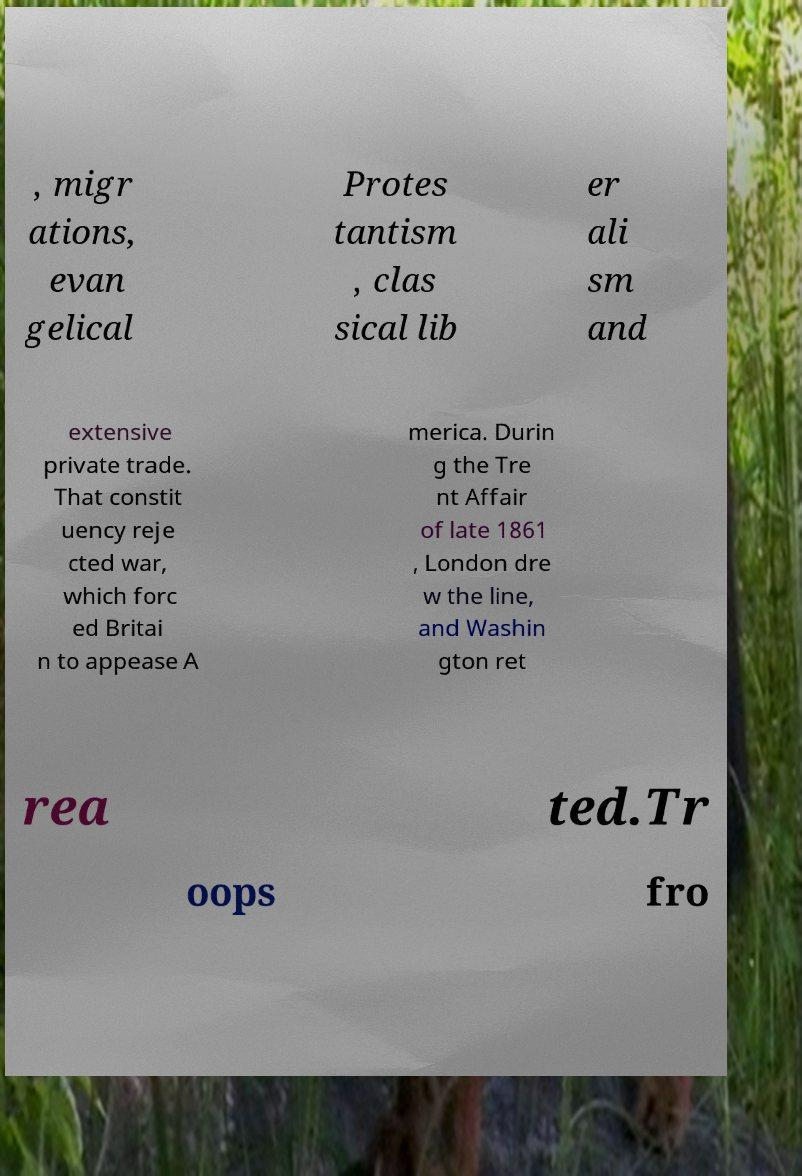I need the written content from this picture converted into text. Can you do that? , migr ations, evan gelical Protes tantism , clas sical lib er ali sm and extensive private trade. That constit uency reje cted war, which forc ed Britai n to appease A merica. Durin g the Tre nt Affair of late 1861 , London dre w the line, and Washin gton ret rea ted.Tr oops fro 